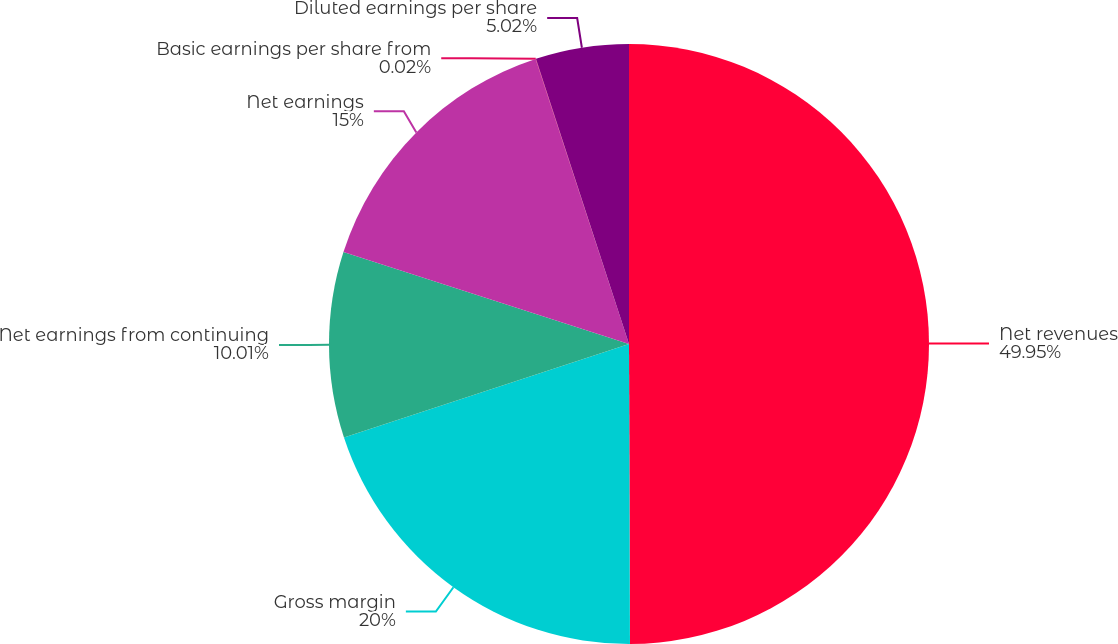Convert chart. <chart><loc_0><loc_0><loc_500><loc_500><pie_chart><fcel>Net revenues<fcel>Gross margin<fcel>Net earnings from continuing<fcel>Net earnings<fcel>Basic earnings per share from<fcel>Diluted earnings per share<nl><fcel>49.95%<fcel>20.0%<fcel>10.01%<fcel>15.0%<fcel>0.02%<fcel>5.02%<nl></chart> 